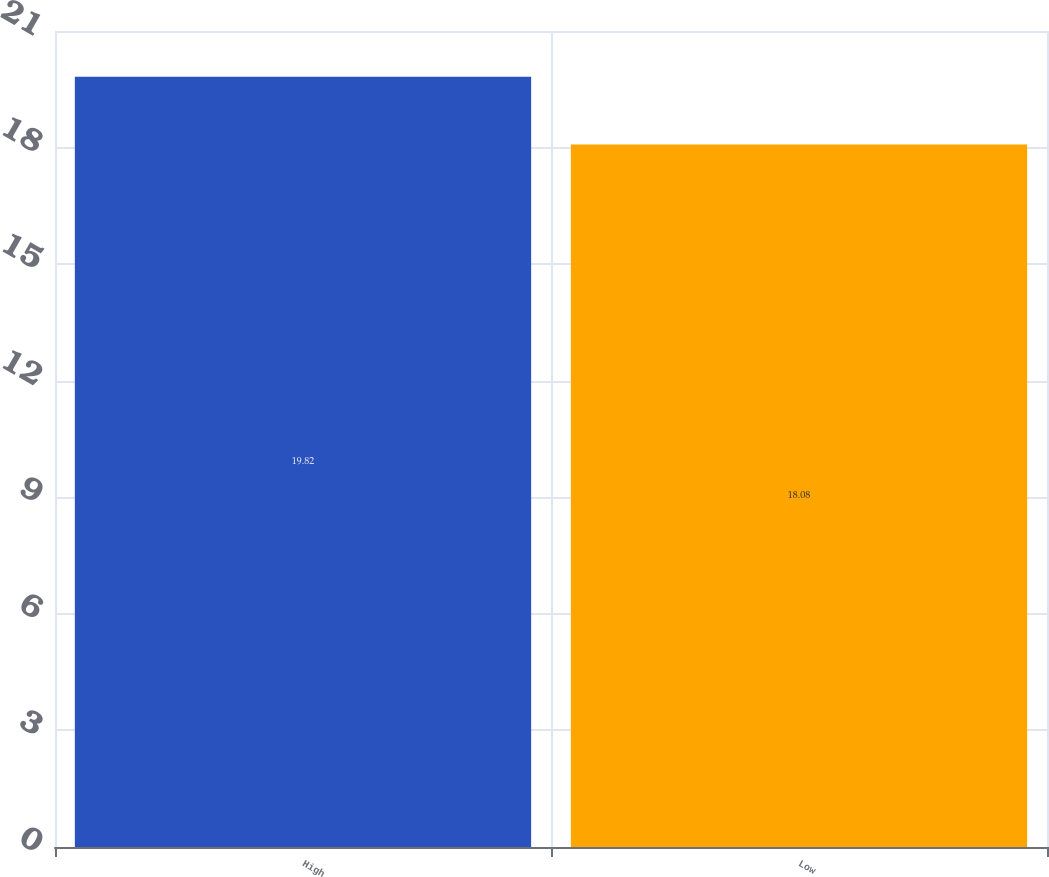Convert chart. <chart><loc_0><loc_0><loc_500><loc_500><bar_chart><fcel>High<fcel>Low<nl><fcel>19.82<fcel>18.08<nl></chart> 